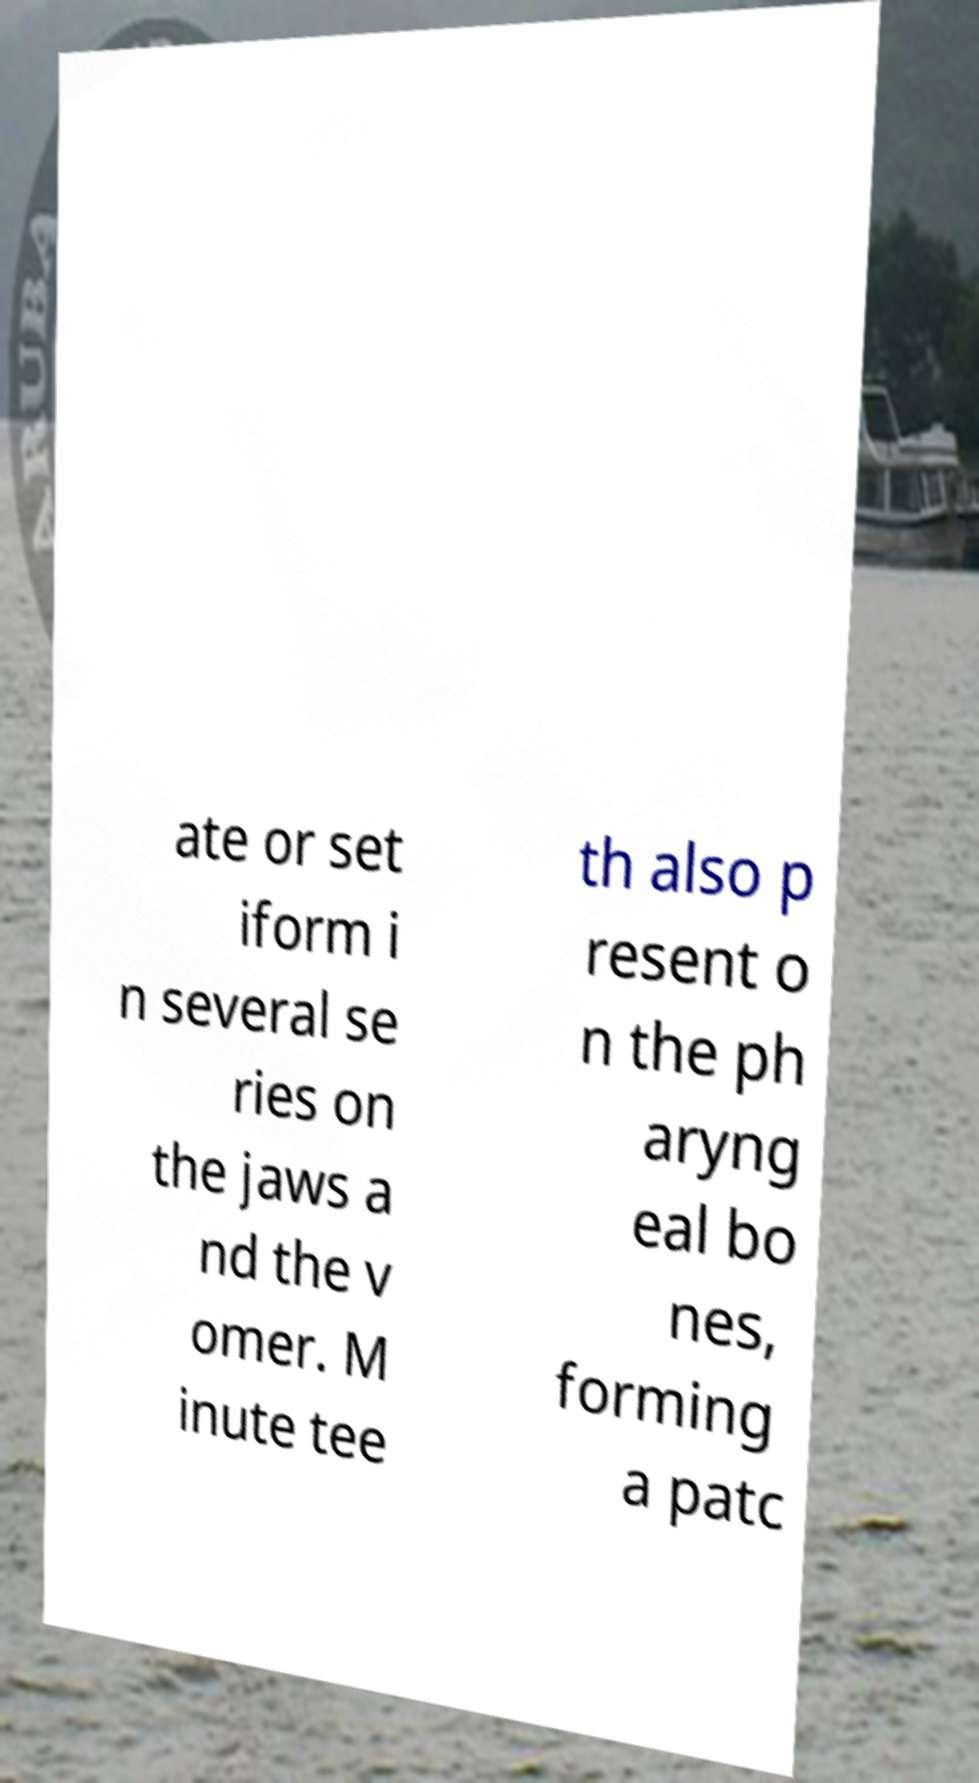There's text embedded in this image that I need extracted. Can you transcribe it verbatim? ate or set iform i n several se ries on the jaws a nd the v omer. M inute tee th also p resent o n the ph aryng eal bo nes, forming a patc 